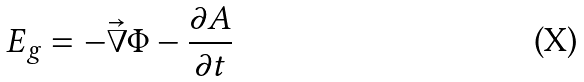Convert formula to latex. <formula><loc_0><loc_0><loc_500><loc_500>E _ { g } = - \vec { \nabla } \Phi - \frac { \partial A } { \partial t }</formula> 